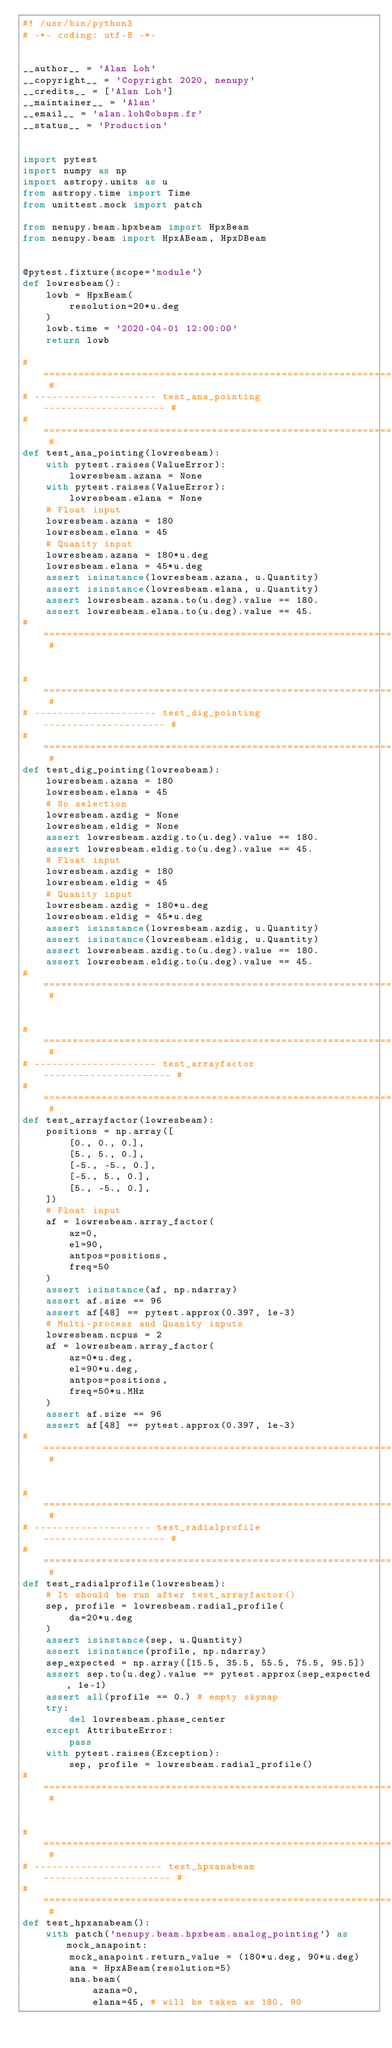<code> <loc_0><loc_0><loc_500><loc_500><_Python_>#! /usr/bin/python3
# -*- coding: utf-8 -*-


__author__ = 'Alan Loh'
__copyright__ = 'Copyright 2020, nenupy'
__credits__ = ['Alan Loh']
__maintainer__ = 'Alan'
__email__ = 'alan.loh@obspm.fr'
__status__ = 'Production'


import pytest
import numpy as np
import astropy.units as u
from astropy.time import Time
from unittest.mock import patch

from nenupy.beam.hpxbeam import HpxBeam
from nenupy.beam import HpxABeam, HpxDBeam


@pytest.fixture(scope='module')
def lowresbeam():
    lowb = HpxBeam(
        resolution=20*u.deg
    )
    lowb.time = '2020-04-01 12:00:00'
    return lowb

# ============================================================= #
# --------------------- test_ana_pointing --------------------- #
# ============================================================= #
def test_ana_pointing(lowresbeam):
    with pytest.raises(ValueError):
        lowresbeam.azana = None
    with pytest.raises(ValueError):
        lowresbeam.elana = None
    # Float input
    lowresbeam.azana = 180
    lowresbeam.elana = 45
    # Quanity input
    lowresbeam.azana = 180*u.deg
    lowresbeam.elana = 45*u.deg
    assert isinstance(lowresbeam.azana, u.Quantity)
    assert isinstance(lowresbeam.elana, u.Quantity)
    assert lowresbeam.azana.to(u.deg).value == 180.
    assert lowresbeam.elana.to(u.deg).value == 45.
# ============================================================= #


# ============================================================= #
# --------------------- test_dig_pointing --------------------- #
# ============================================================= #
def test_dig_pointing(lowresbeam):
    lowresbeam.azana = 180
    lowresbeam.elana = 45
    # No selection
    lowresbeam.azdig = None
    lowresbeam.eldig = None
    assert lowresbeam.azdig.to(u.deg).value == 180.
    assert lowresbeam.eldig.to(u.deg).value == 45. 
    # Float input
    lowresbeam.azdig = 180
    lowresbeam.eldig = 45
    # Quanity input
    lowresbeam.azdig = 180*u.deg
    lowresbeam.eldig = 45*u.deg
    assert isinstance(lowresbeam.azdig, u.Quantity)
    assert isinstance(lowresbeam.eldig, u.Quantity)
    assert lowresbeam.azdig.to(u.deg).value == 180.
    assert lowresbeam.eldig.to(u.deg).value == 45.
# ============================================================= #


# ============================================================= #
# --------------------- test_arrayfactor ---------------------- #
# ============================================================= #
def test_arrayfactor(lowresbeam):
    positions = np.array([
        [0., 0., 0.],
        [5., 5., 0.],
        [-5., -5., 0.],
        [-5., 5., 0.],
        [5., -5., 0.],
    ])
    # Float input
    af = lowresbeam.array_factor(
        az=0,
        el=90,
        antpos=positions,
        freq=50
    )
    assert isinstance(af, np.ndarray)
    assert af.size == 96
    assert af[48] == pytest.approx(0.397, 1e-3)
    # Multi-process and Quanity inputs
    lowresbeam.ncpus = 2
    af = lowresbeam.array_factor(
        az=0*u.deg,
        el=90*u.deg,
        antpos=positions,
        freq=50*u.MHz
    )
    assert af.size == 96
    assert af[48] == pytest.approx(0.397, 1e-3)
# ============================================================= #


# ============================================================= #
# -------------------- test_radialprofile --------------------- #
# ============================================================= #
def test_radialprofile(lowresbeam):
    # It should be run after test_arrayfactor()
    sep, profile = lowresbeam.radial_profile(
        da=20*u.deg
    )
    assert isinstance(sep, u.Quantity)
    assert isinstance(profile, np.ndarray)
    sep_expected = np.array([15.5, 35.5, 55.5, 75.5, 95.5])
    assert sep.to(u.deg).value == pytest.approx(sep_expected, 1e-1)
    assert all(profile == 0.) # empty skymap
    try:
        del lowresbeam.phase_center
    except AttributeError:
        pass
    with pytest.raises(Exception):
        sep, profile = lowresbeam.radial_profile()
# ============================================================= #


# ============================================================= #
# ---------------------- test_hpxanabeam ---------------------- #
# ============================================================= #
def test_hpxanabeam():
    with patch('nenupy.beam.hpxbeam.analog_pointing') as mock_anapoint:
        mock_anapoint.return_value = (180*u.deg, 90*u.deg)
        ana = HpxABeam(resolution=5)
        ana.beam(
            azana=0,
            elana=45, # will be taken as 180, 90</code> 